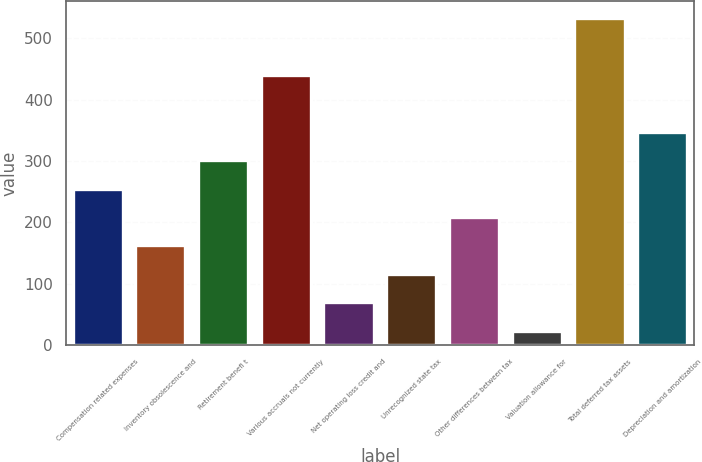Convert chart. <chart><loc_0><loc_0><loc_500><loc_500><bar_chart><fcel>Compensation related expenses<fcel>Inventory obsolescence and<fcel>Retirement benefi t<fcel>Various accruals not currently<fcel>Net operating loss credit and<fcel>Unrecognized state tax<fcel>Other differences between tax<fcel>Valuation allowance for<fcel>Total deferred tax assets<fcel>Depreciation and amortization<nl><fcel>255.25<fcel>162.55<fcel>301.6<fcel>440.65<fcel>69.85<fcel>116.2<fcel>208.9<fcel>23.5<fcel>533.35<fcel>347.95<nl></chart> 